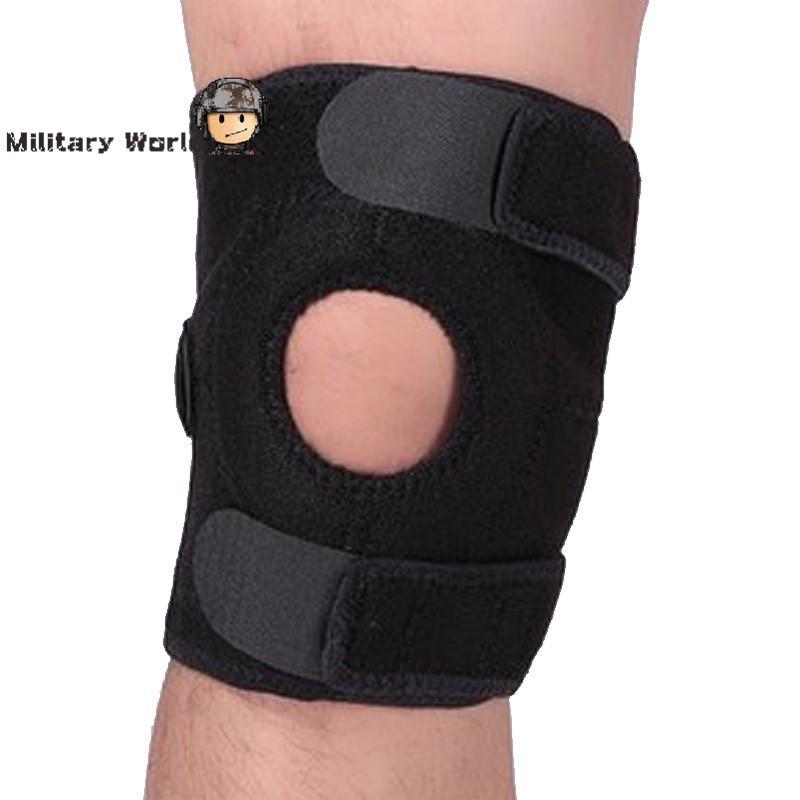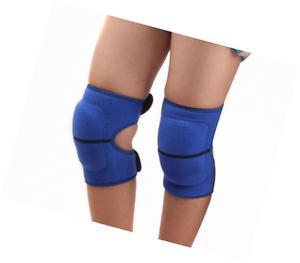The first image is the image on the left, the second image is the image on the right. Assess this claim about the two images: "The right image contains at least one pair of legs.". Correct or not? Answer yes or no. Yes. 